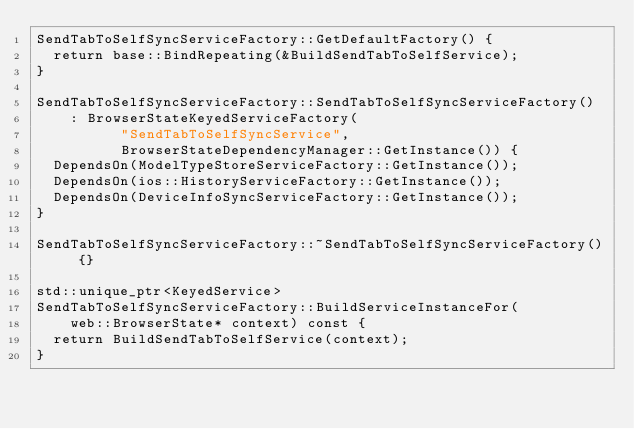<code> <loc_0><loc_0><loc_500><loc_500><_ObjectiveC_>SendTabToSelfSyncServiceFactory::GetDefaultFactory() {
  return base::BindRepeating(&BuildSendTabToSelfService);
}

SendTabToSelfSyncServiceFactory::SendTabToSelfSyncServiceFactory()
    : BrowserStateKeyedServiceFactory(
          "SendTabToSelfSyncService",
          BrowserStateDependencyManager::GetInstance()) {
  DependsOn(ModelTypeStoreServiceFactory::GetInstance());
  DependsOn(ios::HistoryServiceFactory::GetInstance());
  DependsOn(DeviceInfoSyncServiceFactory::GetInstance());
}

SendTabToSelfSyncServiceFactory::~SendTabToSelfSyncServiceFactory() {}

std::unique_ptr<KeyedService>
SendTabToSelfSyncServiceFactory::BuildServiceInstanceFor(
    web::BrowserState* context) const {
  return BuildSendTabToSelfService(context);
}
</code> 